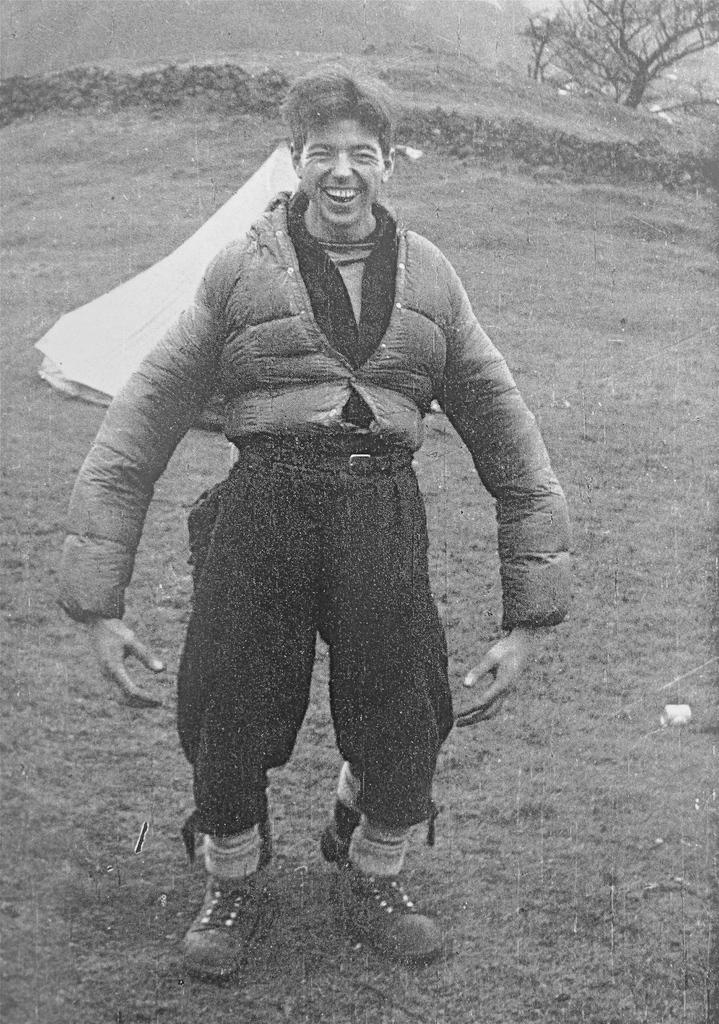What is the man in the image doing? The man is standing in the image. What is the man's facial expression? The man is smiling. What type of vegetation is in the foreground of the image? There is grass in the foreground of the image. What is the white object in the middle of the image? There is a white color object in the middle of the image. What type of objects can be seen in the background of the image? There are stones and trees in the background of the image. What type of alley can be seen in the image? There is no alley present in the image. What type of crack is visible on the ground in the image? There is no crack visible on the ground in the image. 